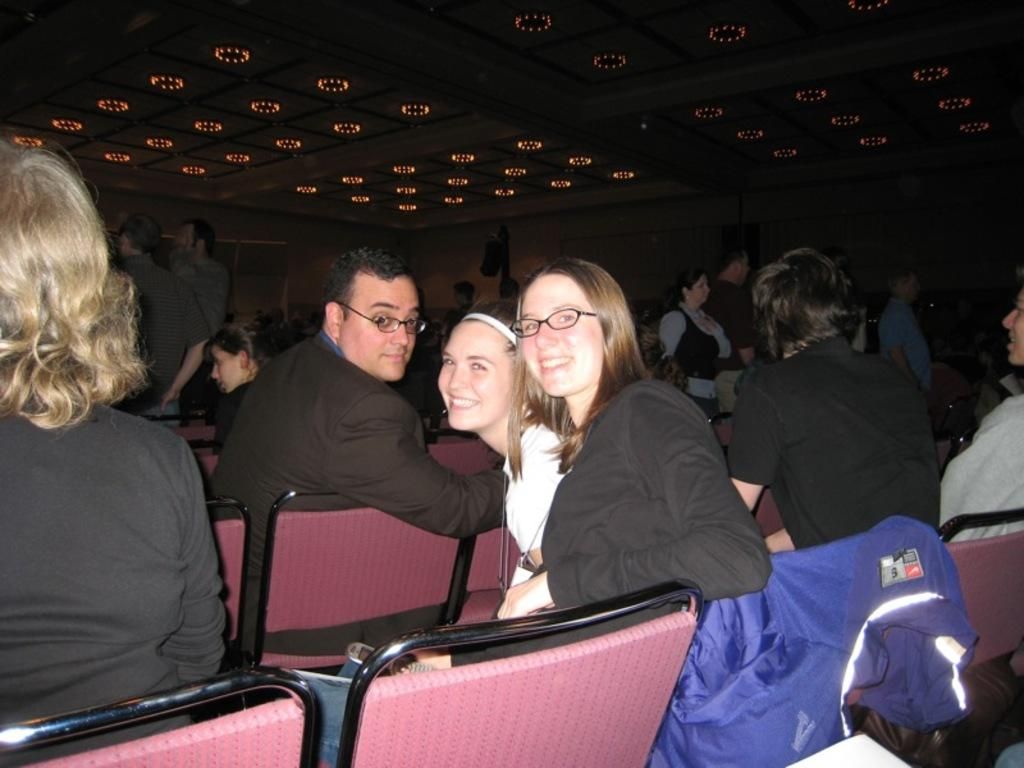Who or what can be seen in the image? There are people in the image. What objects are present that the people might use for sitting? There are chairs in the image. What can be seen at the top of the image? There are lights visible at the top of the image. What type of impulse can be seen affecting the people in the image? There is no indication of any impulse affecting the people in the image. Is there a protest taking place in the image? There is no indication of a protest in the image. 